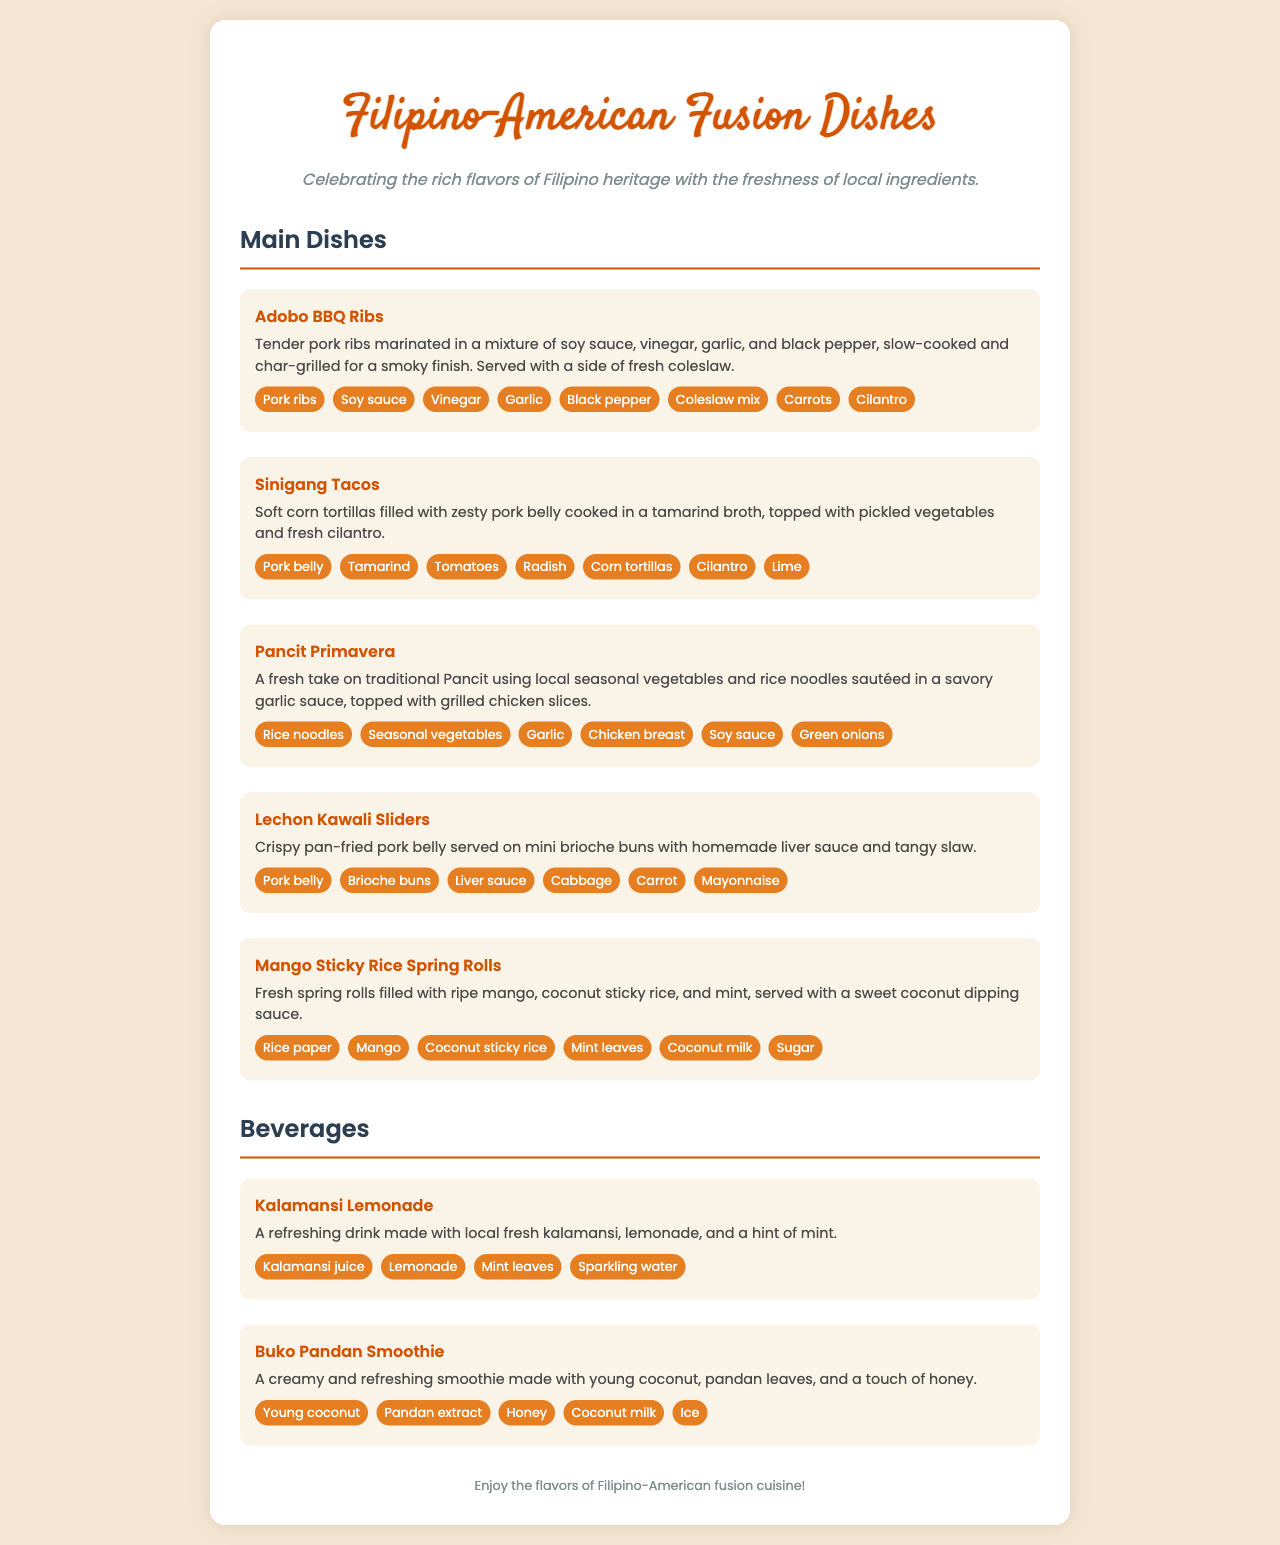what is the first dish listed on the menu? The first dish mentioned in the menu under 'Main Dishes' is 'Adobo BBQ Ribs'.
Answer: Adobo BBQ Ribs how many main dishes are there? The document lists a total of five main dishes under the 'Main Dishes' section.
Answer: 5 what type of beverage is featured alongside 'Buko Pandan Smoothie'? The beverage featured alongside 'Buko Pandan Smoothie' is 'Kalamansi Lemonade'.
Answer: Kalamansi Lemonade what ingredient is common in both 'Pancit Primavera' and 'Sinigang Tacos'? Both 'Pancit Primavera' and 'Sinigang Tacos' include the ingredient 'Cilantro'.
Answer: Cilantro which dish contains coconut sticky rice? The dish that contains coconut sticky rice is 'Mango Sticky Rice Spring Rolls'.
Answer: Mango Sticky Rice Spring Rolls 